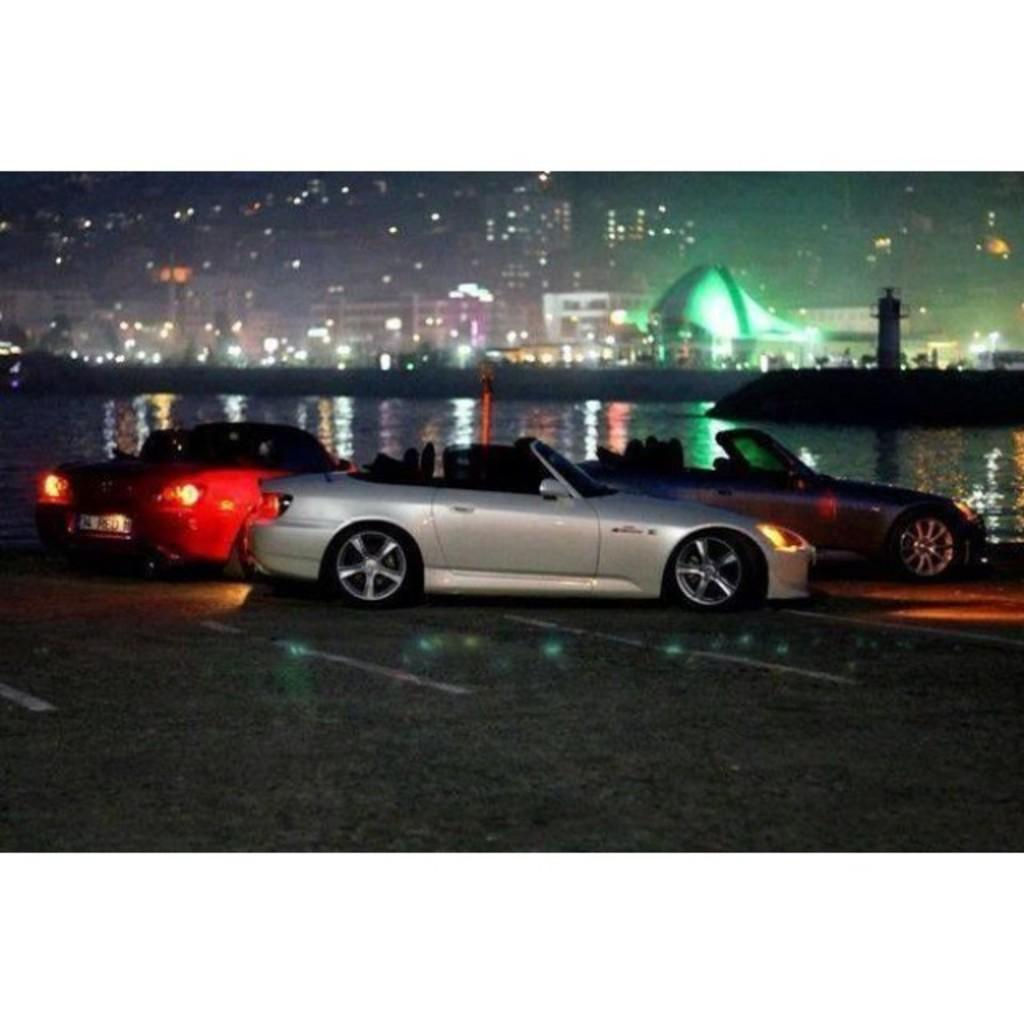What can be seen in the center of the image? There are cars on the road in the center of the image. What is visible in the background of the image? Water, a lighthouse, buildings, and lights can be seen in the background of the image. What is located at the bottom of the image? There is a road at the bottom of the image. What type of sweater is the lighthouse wearing in the image? Lighthouses do not wear sweaters, as they are inanimate objects. 